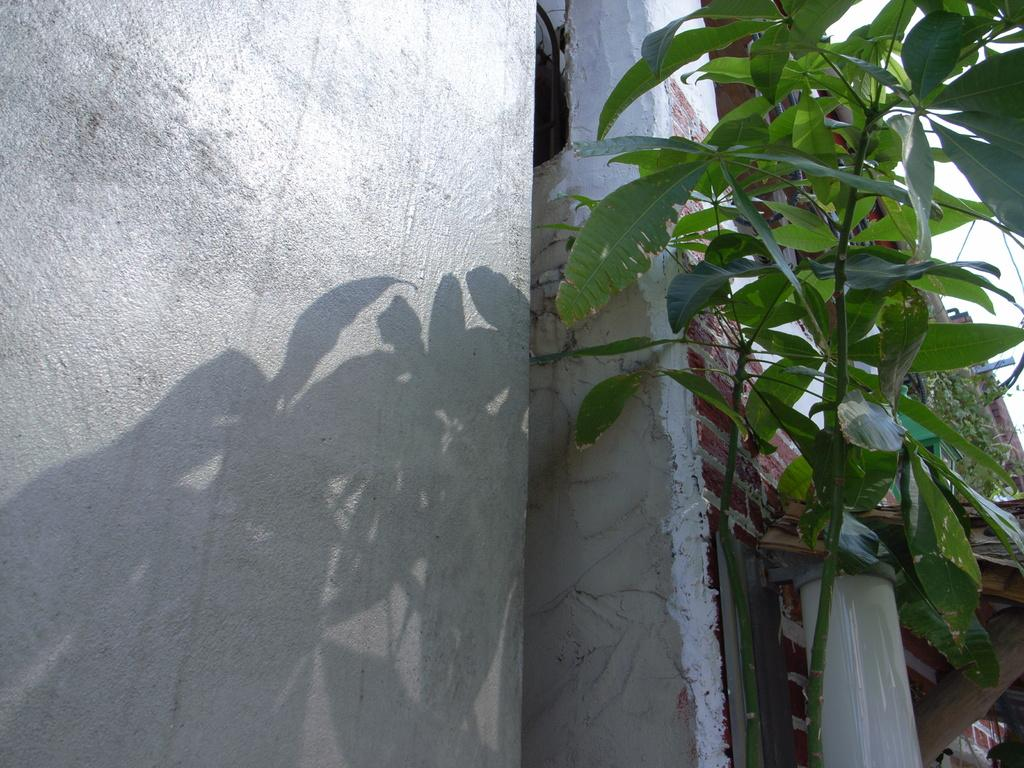What type of living organism can be seen in the image? There is a plant in the image. Where is the plant located in relation to other objects? The plant is in front of a wall. What is attached to the wall in the image? There is a pipe attached to the wall. What can be seen in the background of the image? The sky is visible in the background of the image. What type of linen is draped over the plant in the image? There is no linen present in the image; it only features a plant, a wall, a pipe, and the sky. 